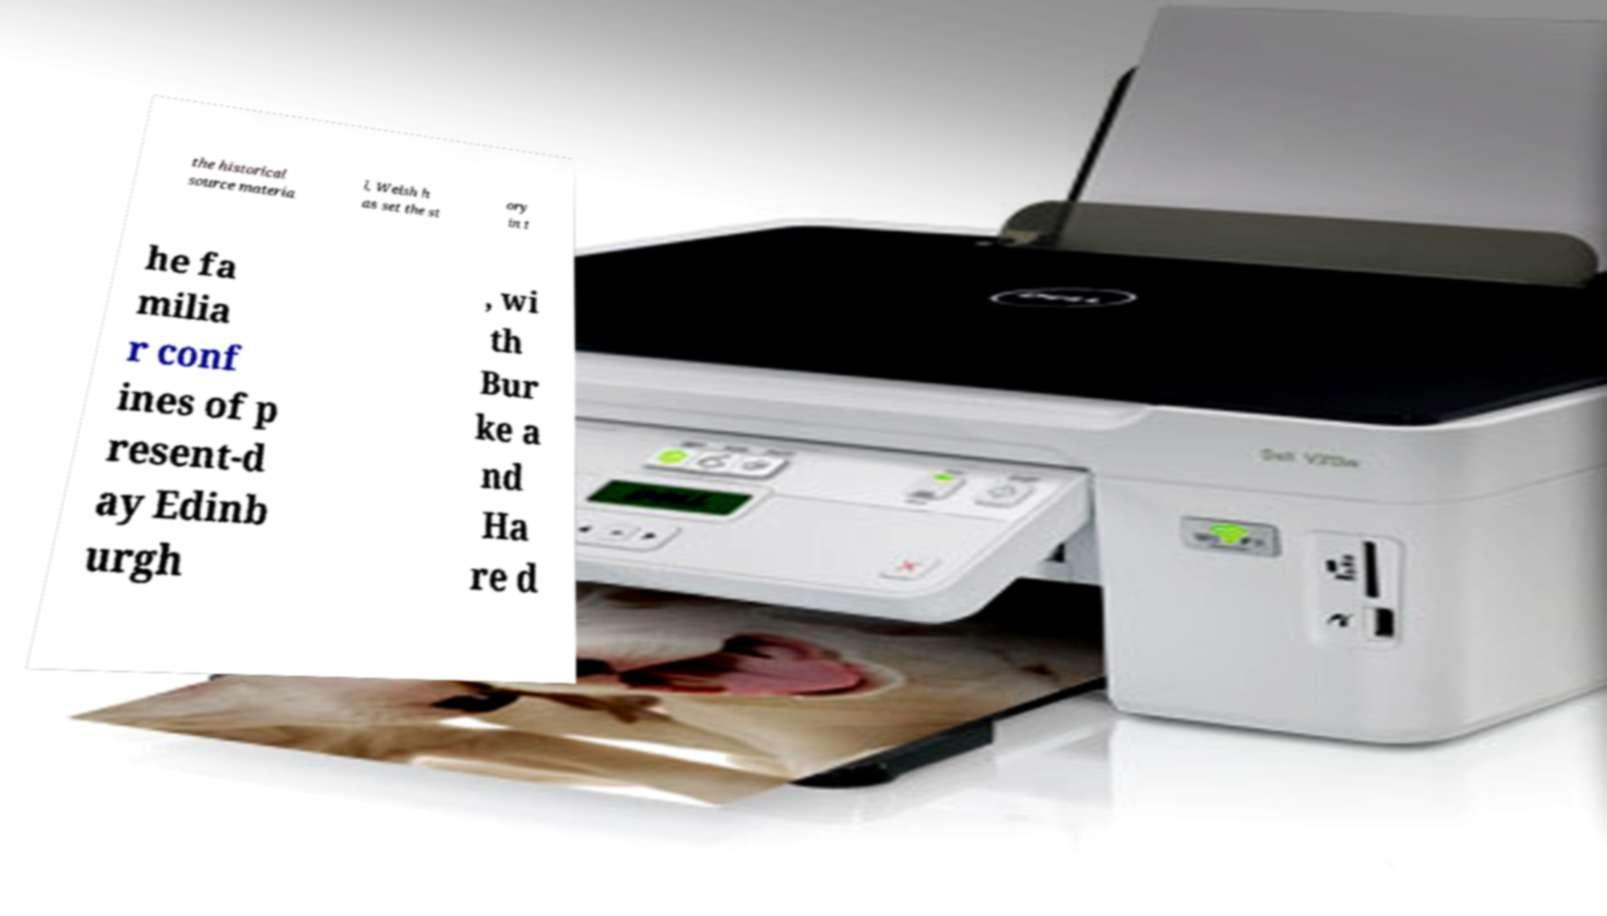I need the written content from this picture converted into text. Can you do that? the historical source materia l, Welsh h as set the st ory in t he fa milia r conf ines of p resent-d ay Edinb urgh , wi th Bur ke a nd Ha re d 